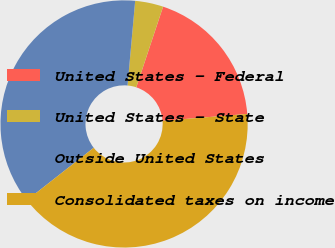<chart> <loc_0><loc_0><loc_500><loc_500><pie_chart><fcel>United States - Federal<fcel>United States - State<fcel>Outside United States<fcel>Consolidated taxes on income<nl><fcel>18.6%<fcel>3.68%<fcel>37.02%<fcel>40.7%<nl></chart> 